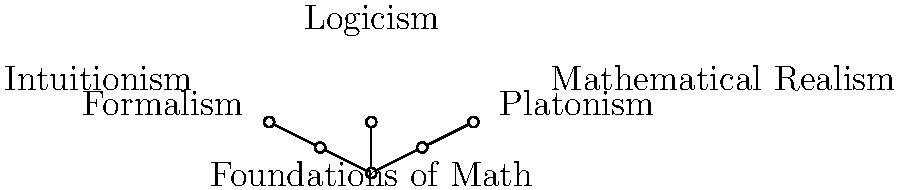Given the concept map of philosophical arguments on the foundations of mathematics, which clustering approach would be most appropriate to group these philosophical positions, and why might this be problematic from the perspective of a critic of foundationalism? To answer this question, let's follow these steps:

1. Analyze the concept map:
   The map shows "Foundations of Math" as the central node, with three main branches: Platonism, Formalism, and Logicism. Platonism further branches to Mathematical Realism, while Formalism branches to Intuitionism.

2. Consider clustering approaches:
   a) Hierarchical clustering could be applied, grouping nodes based on their connections.
   b) K-means clustering could be used, but would require defining a distance metric between philosophical positions.
   c) Spectral clustering might be appropriate, as it can capture the graph structure of the concept map.

3. Most appropriate approach:
   Hierarchical clustering would be most suitable here, as it naturally captures the tree-like structure of the concept map.

4. Application of hierarchical clustering:
   - Level 1: {Foundations of Math}
   - Level 2: {Platonism, Formalism, Logicism}
   - Level 3: {Mathematical Realism, Intuitionism}

5. Critique from a foundationalism critic:
   A critic might argue that this clustering:
   a) Oversimplifies complex philosophical positions
   b) Implies a hierarchical relationship that may not exist
   c) Neglects the interconnectedness of these theories
   d) Fails to capture nuances and overlaps between positions

6. Problematic aspects:
   - The clustering suggests clear boundaries between theories, which may not reflect reality.
   - It implies that "Foundations of Math" is a coherent, unified concept, which a critic might dispute.
   - The hierarchical structure could be seen as reinforcing the foundationalist assumption that mathematics needs or has foundations.

Therefore, while hierarchical clustering fits the given concept map, it may reinforce assumptions that a critic of foundationalism would challenge.
Answer: Hierarchical clustering; reinforces foundationalist assumptions 